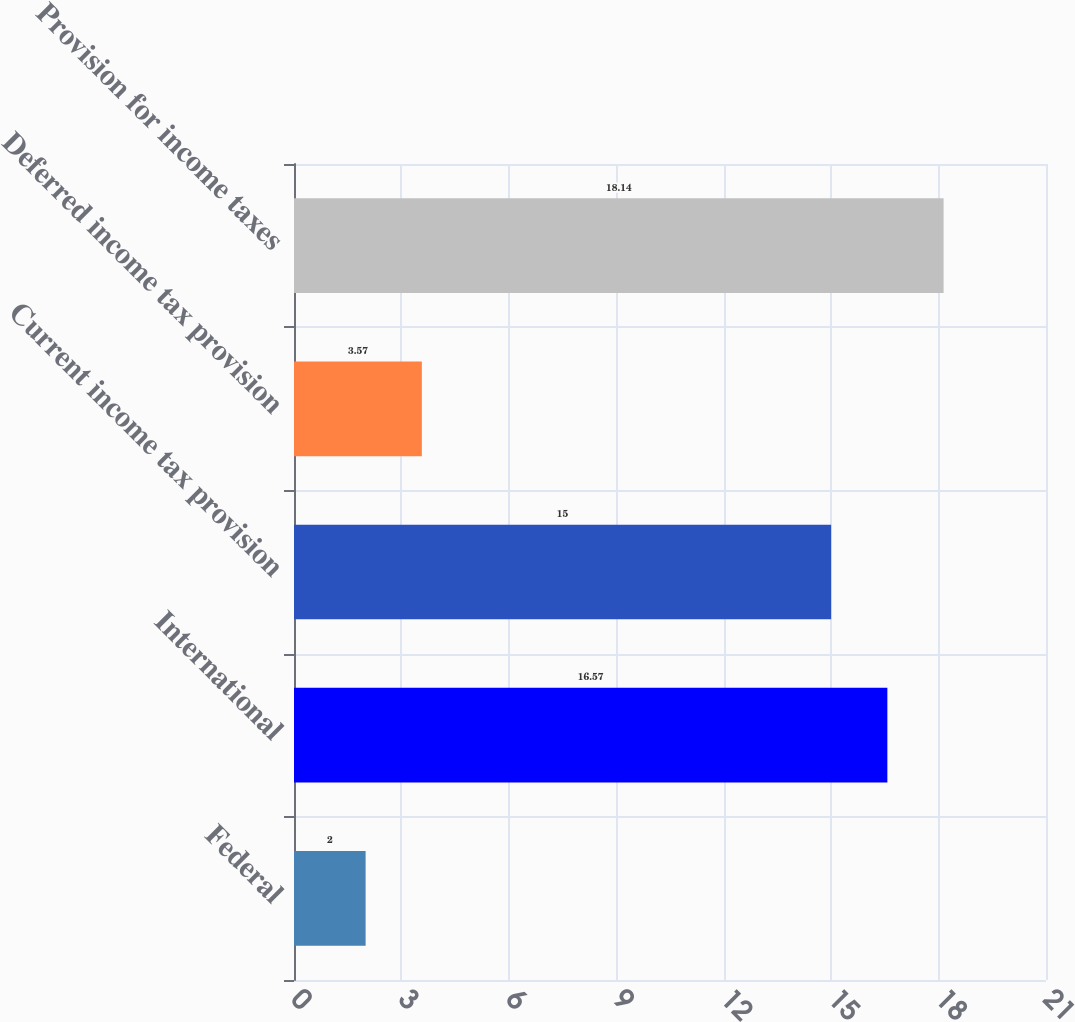Convert chart. <chart><loc_0><loc_0><loc_500><loc_500><bar_chart><fcel>Federal<fcel>International<fcel>Current income tax provision<fcel>Deferred income tax provision<fcel>Provision for income taxes<nl><fcel>2<fcel>16.57<fcel>15<fcel>3.57<fcel>18.14<nl></chart> 